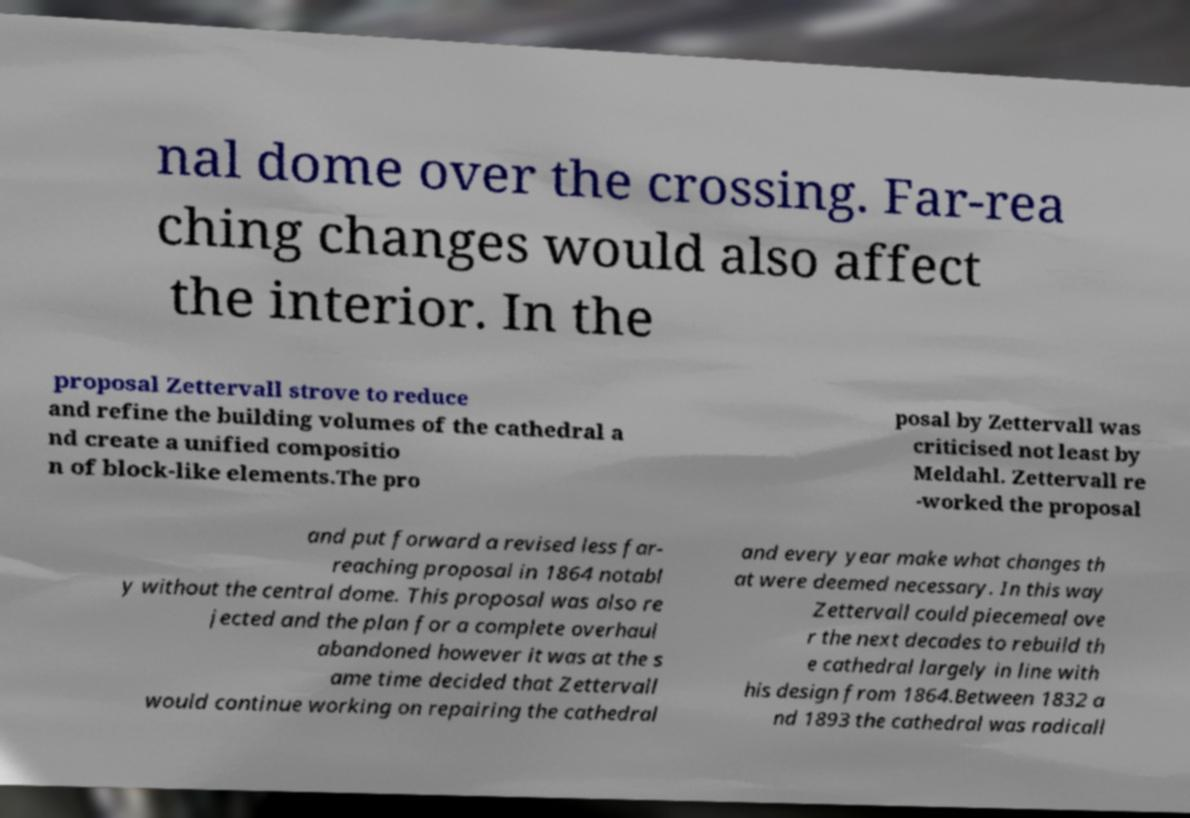Please read and relay the text visible in this image. What does it say? nal dome over the crossing. Far-rea ching changes would also affect the interior. In the proposal Zettervall strove to reduce and refine the building volumes of the cathedral a nd create a unified compositio n of block-like elements.The pro posal by Zettervall was criticised not least by Meldahl. Zettervall re -worked the proposal and put forward a revised less far- reaching proposal in 1864 notabl y without the central dome. This proposal was also re jected and the plan for a complete overhaul abandoned however it was at the s ame time decided that Zettervall would continue working on repairing the cathedral and every year make what changes th at were deemed necessary. In this way Zettervall could piecemeal ove r the next decades to rebuild th e cathedral largely in line with his design from 1864.Between 1832 a nd 1893 the cathedral was radicall 